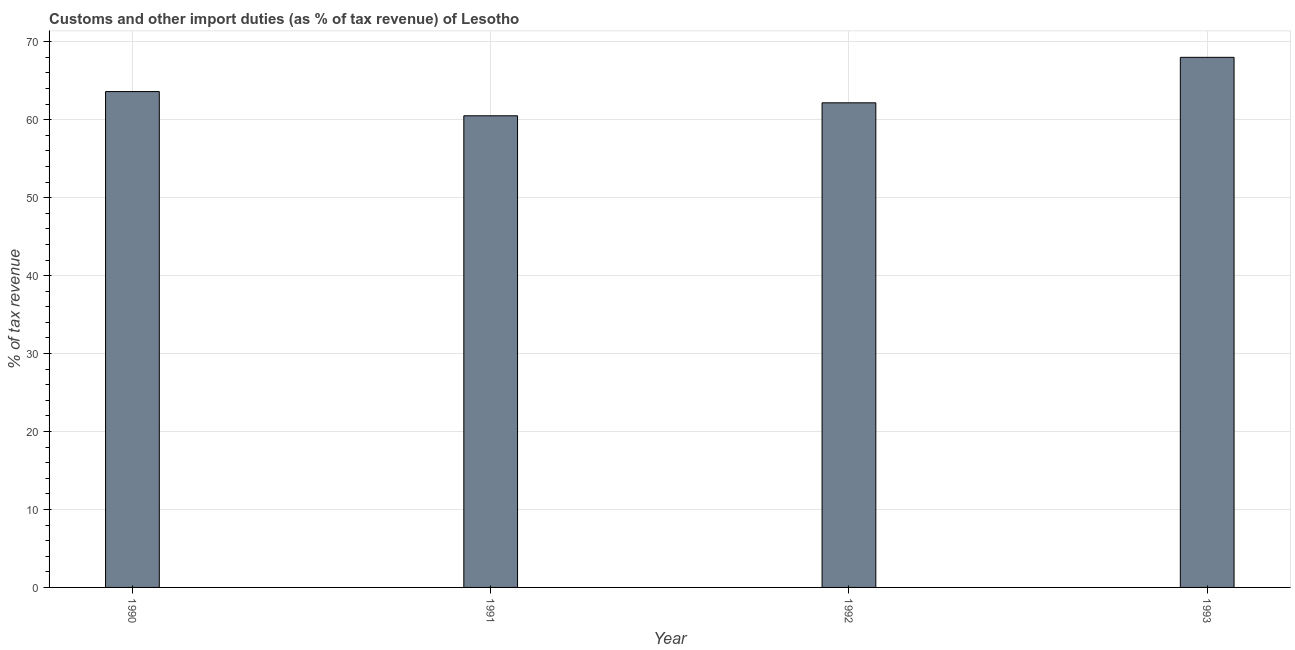Does the graph contain any zero values?
Offer a very short reply. No. What is the title of the graph?
Provide a short and direct response. Customs and other import duties (as % of tax revenue) of Lesotho. What is the label or title of the Y-axis?
Your answer should be very brief. % of tax revenue. What is the customs and other import duties in 1991?
Make the answer very short. 60.51. Across all years, what is the maximum customs and other import duties?
Your response must be concise. 68.01. Across all years, what is the minimum customs and other import duties?
Make the answer very short. 60.51. In which year was the customs and other import duties minimum?
Your answer should be compact. 1991. What is the sum of the customs and other import duties?
Give a very brief answer. 254.31. What is the difference between the customs and other import duties in 1990 and 1991?
Keep it short and to the point. 3.11. What is the average customs and other import duties per year?
Your answer should be very brief. 63.58. What is the median customs and other import duties?
Provide a succinct answer. 62.89. Do a majority of the years between 1993 and 1992 (inclusive) have customs and other import duties greater than 54 %?
Offer a very short reply. No. What is the ratio of the customs and other import duties in 1990 to that in 1992?
Your answer should be very brief. 1.02. Is the customs and other import duties in 1990 less than that in 1993?
Your answer should be compact. Yes. What is the difference between the highest and the second highest customs and other import duties?
Provide a succinct answer. 4.39. What is the difference between the highest and the lowest customs and other import duties?
Your answer should be compact. 7.5. How many bars are there?
Your response must be concise. 4. Are all the bars in the graph horizontal?
Ensure brevity in your answer.  No. What is the difference between two consecutive major ticks on the Y-axis?
Provide a short and direct response. 10. What is the % of tax revenue in 1990?
Make the answer very short. 63.62. What is the % of tax revenue of 1991?
Provide a short and direct response. 60.51. What is the % of tax revenue in 1992?
Keep it short and to the point. 62.17. What is the % of tax revenue of 1993?
Provide a succinct answer. 68.01. What is the difference between the % of tax revenue in 1990 and 1991?
Provide a short and direct response. 3.11. What is the difference between the % of tax revenue in 1990 and 1992?
Your answer should be very brief. 1.44. What is the difference between the % of tax revenue in 1990 and 1993?
Give a very brief answer. -4.39. What is the difference between the % of tax revenue in 1991 and 1992?
Provide a succinct answer. -1.66. What is the difference between the % of tax revenue in 1991 and 1993?
Give a very brief answer. -7.5. What is the difference between the % of tax revenue in 1992 and 1993?
Keep it short and to the point. -5.84. What is the ratio of the % of tax revenue in 1990 to that in 1991?
Make the answer very short. 1.05. What is the ratio of the % of tax revenue in 1990 to that in 1992?
Offer a very short reply. 1.02. What is the ratio of the % of tax revenue in 1990 to that in 1993?
Make the answer very short. 0.94. What is the ratio of the % of tax revenue in 1991 to that in 1993?
Keep it short and to the point. 0.89. What is the ratio of the % of tax revenue in 1992 to that in 1993?
Make the answer very short. 0.91. 